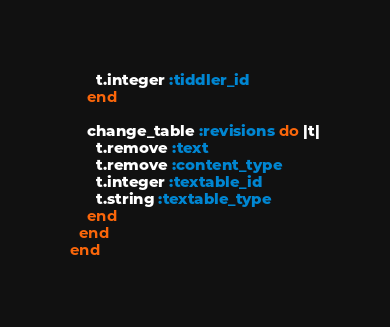Convert code to text. <code><loc_0><loc_0><loc_500><loc_500><_Ruby_>      t.integer :tiddler_id
    end

    change_table :revisions do |t|
      t.remove :text
      t.remove :content_type
      t.integer :textable_id
      t.string :textable_type
    end
  end
end
</code> 